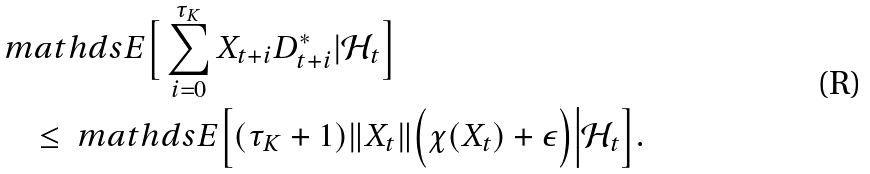<formula> <loc_0><loc_0><loc_500><loc_500>& \ m a t h d s { E } \Big [ \sum _ { i = 0 } ^ { \tau _ { K } } X _ { t + i } D ^ { * } _ { t + i } | \mathcal { H } _ { t } \Big ] \\ & \quad \leq \ m a t h d s { E } \Big [ ( \tau _ { K } + 1 ) \| X _ { t } \| \Big ( \chi ( X _ { t } ) + \epsilon \Big ) \Big | \mathcal { H } _ { t } \Big ] .</formula> 